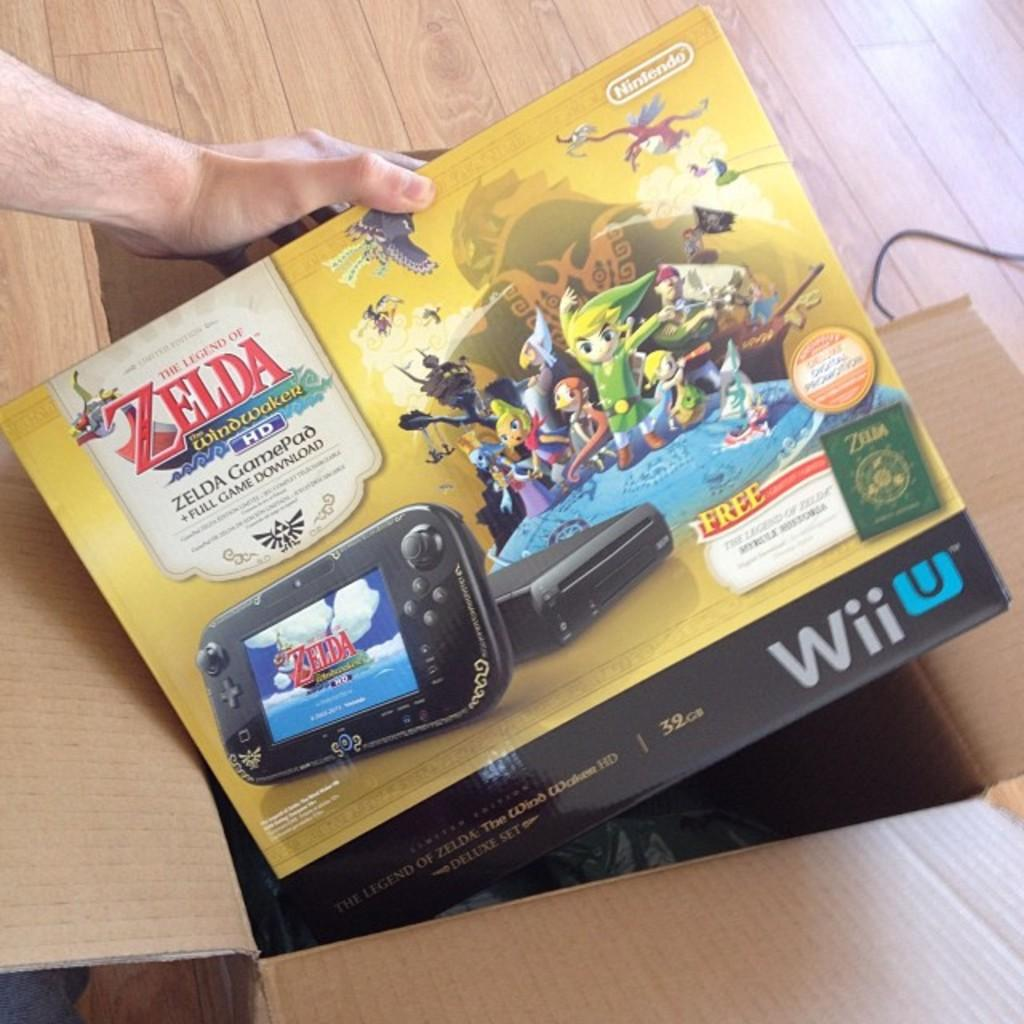<image>
Summarize the visual content of the image. Someone takes a Zelda GamePad out of a cardboard box. 